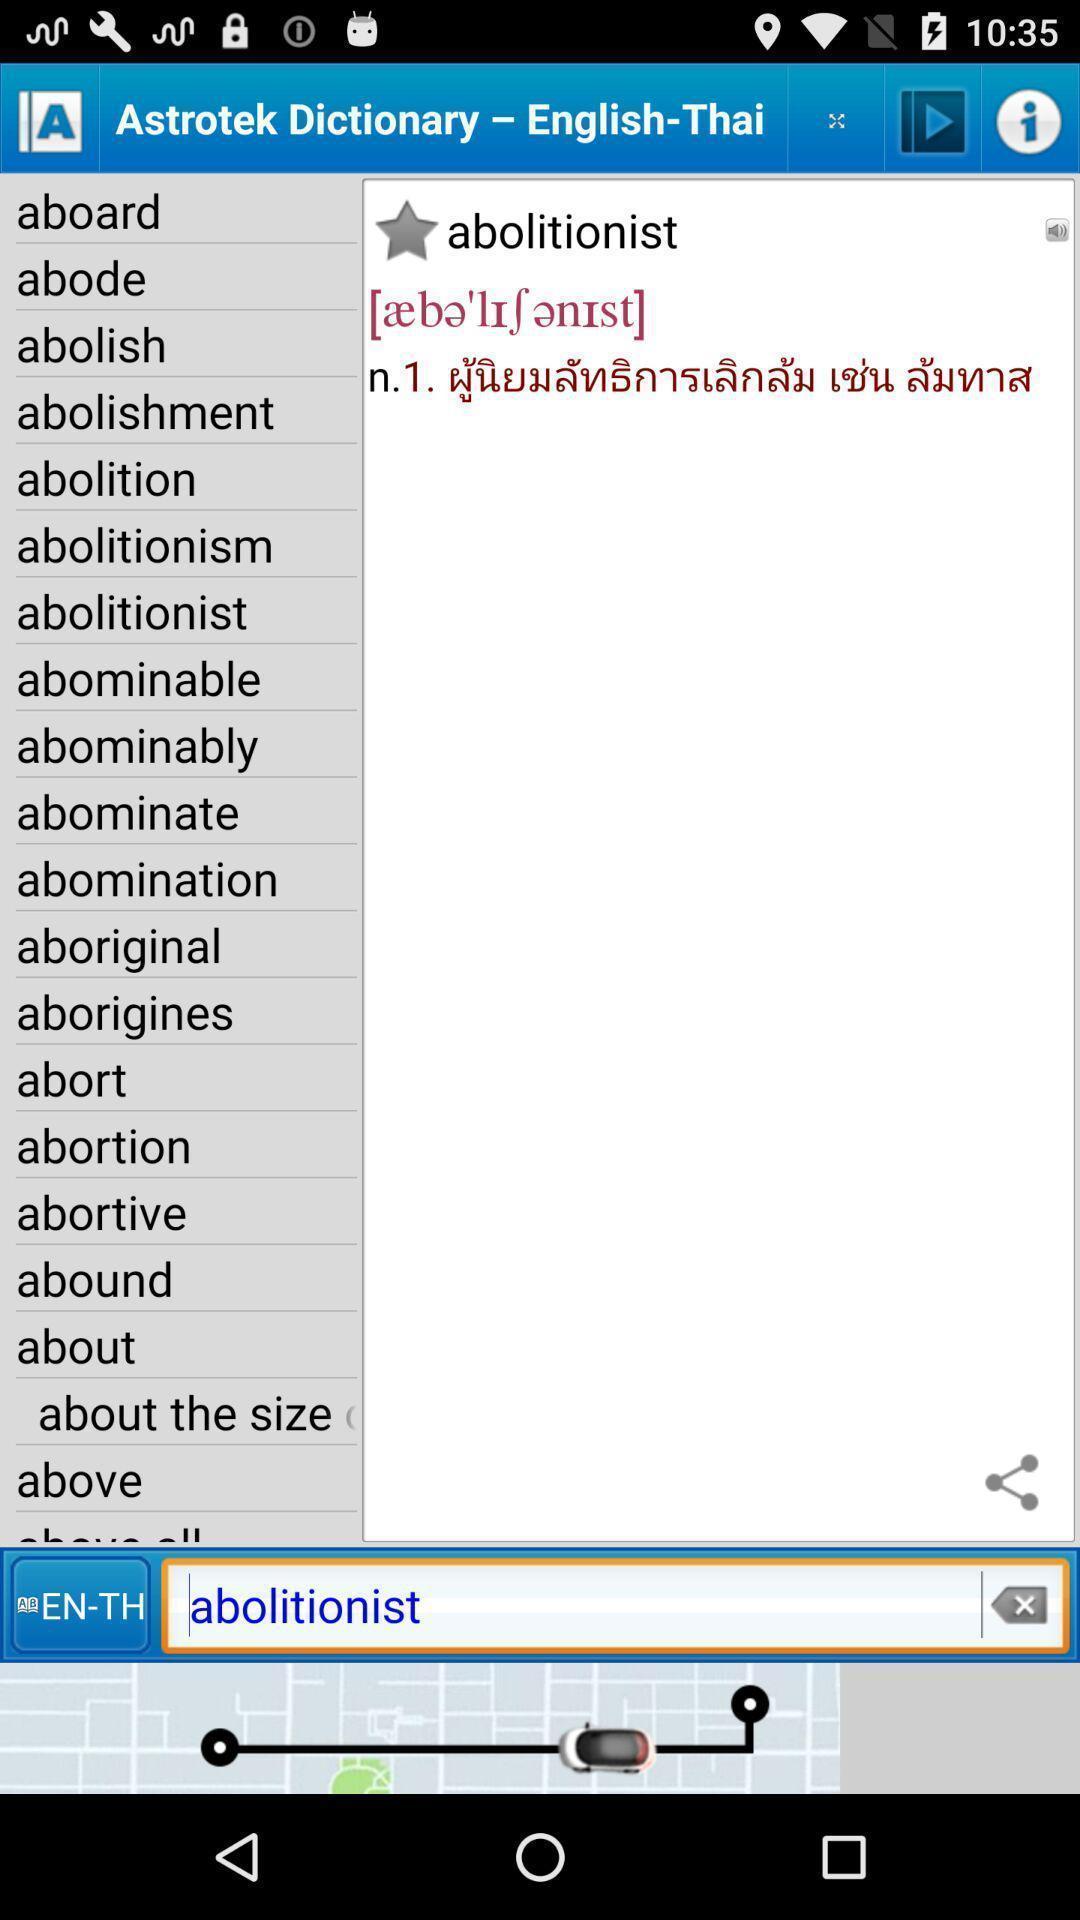Explain what's happening in this screen capture. Screen shows list of words in an learning app. 